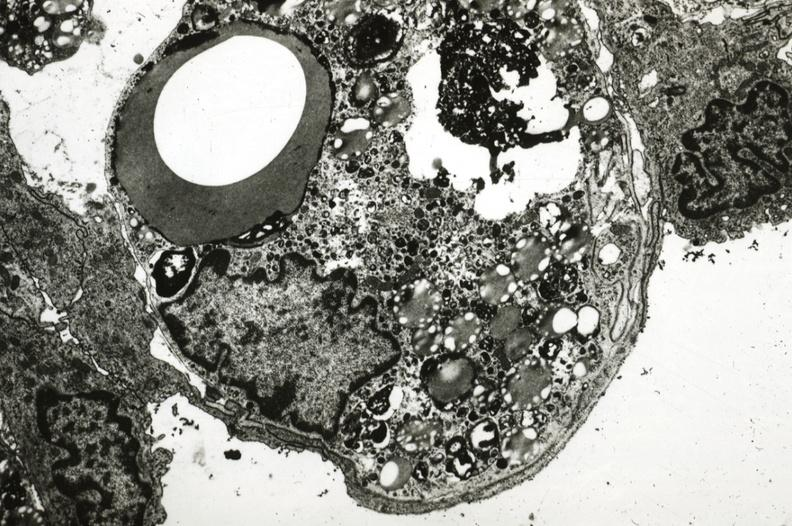what is present?
Answer the question using a single word or phrase. Atherosclerosis 